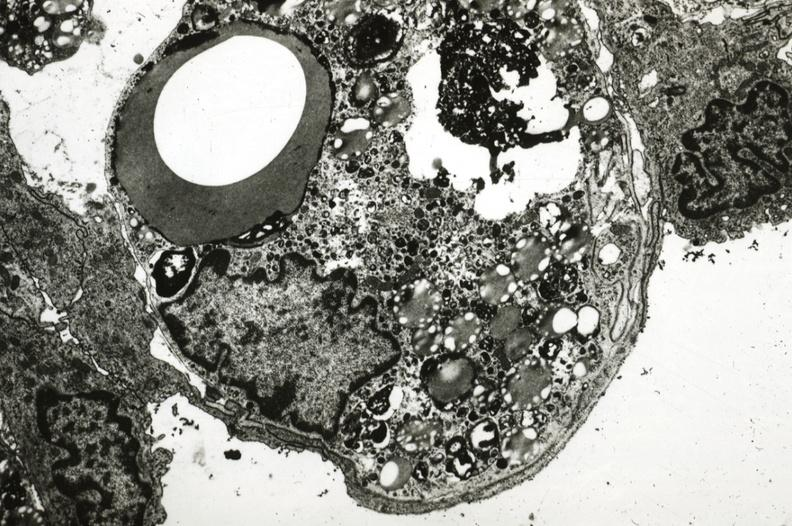what is present?
Answer the question using a single word or phrase. Atherosclerosis 